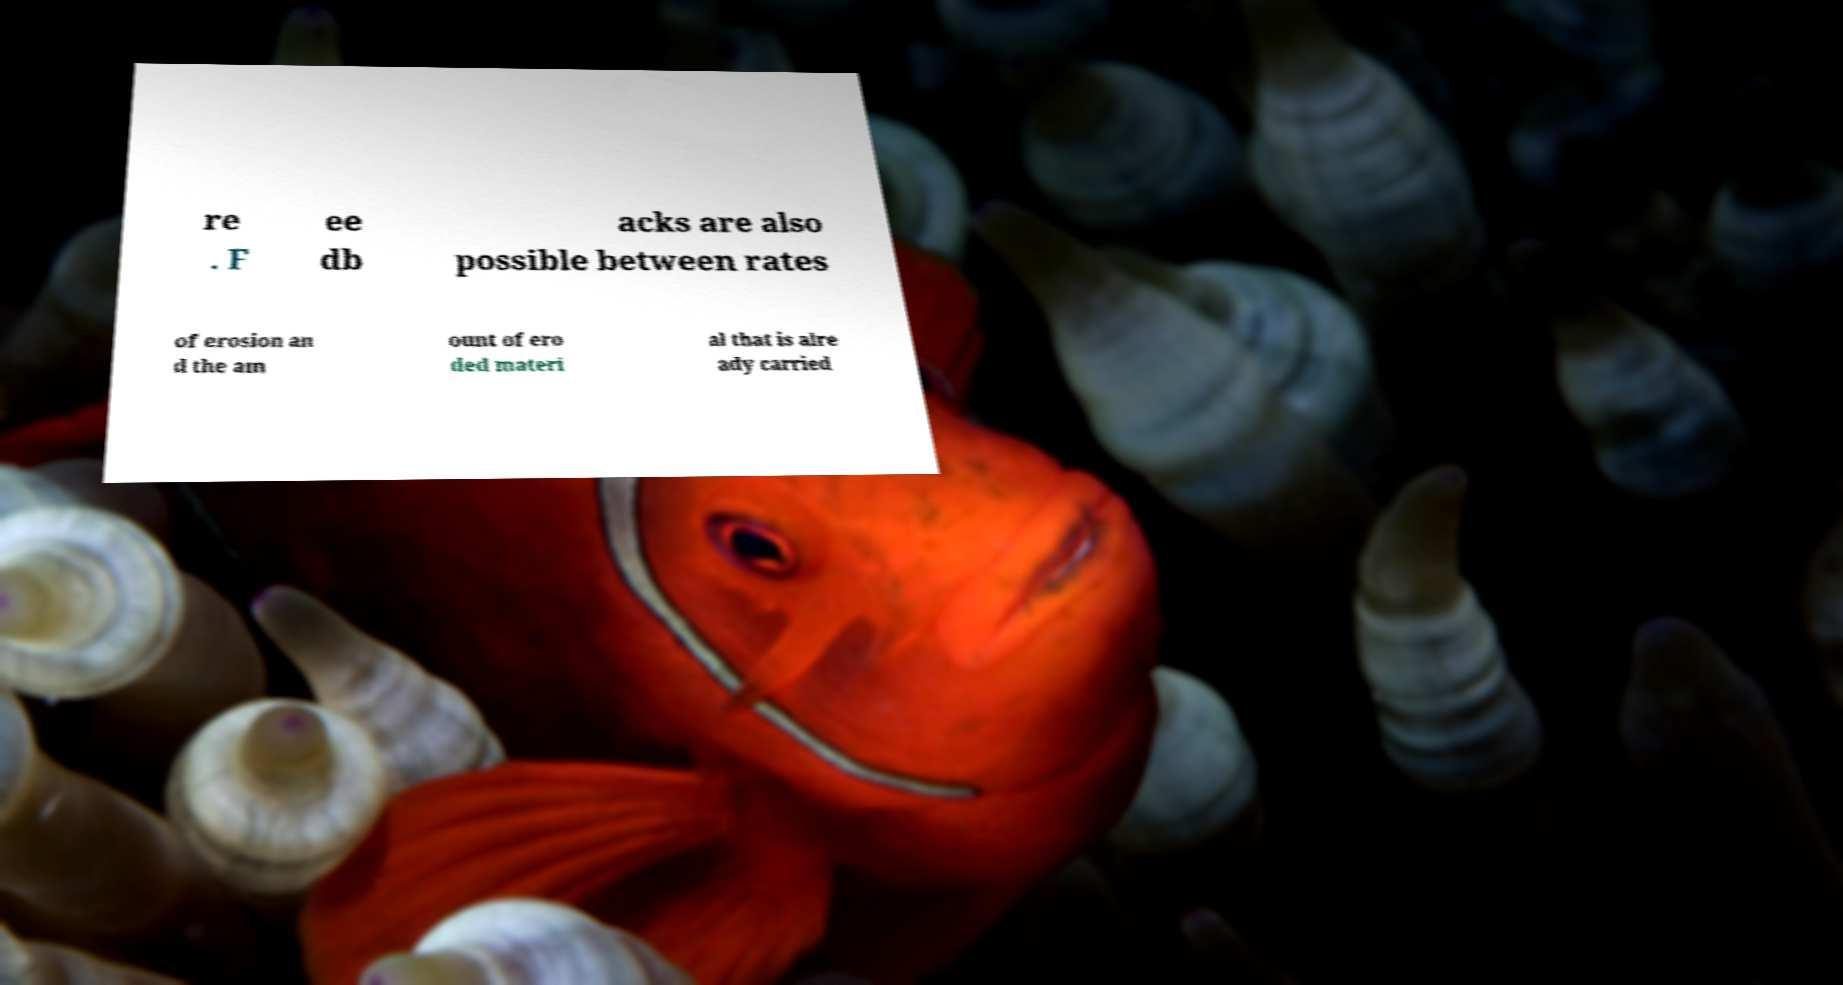I need the written content from this picture converted into text. Can you do that? re . F ee db acks are also possible between rates of erosion an d the am ount of ero ded materi al that is alre ady carried 